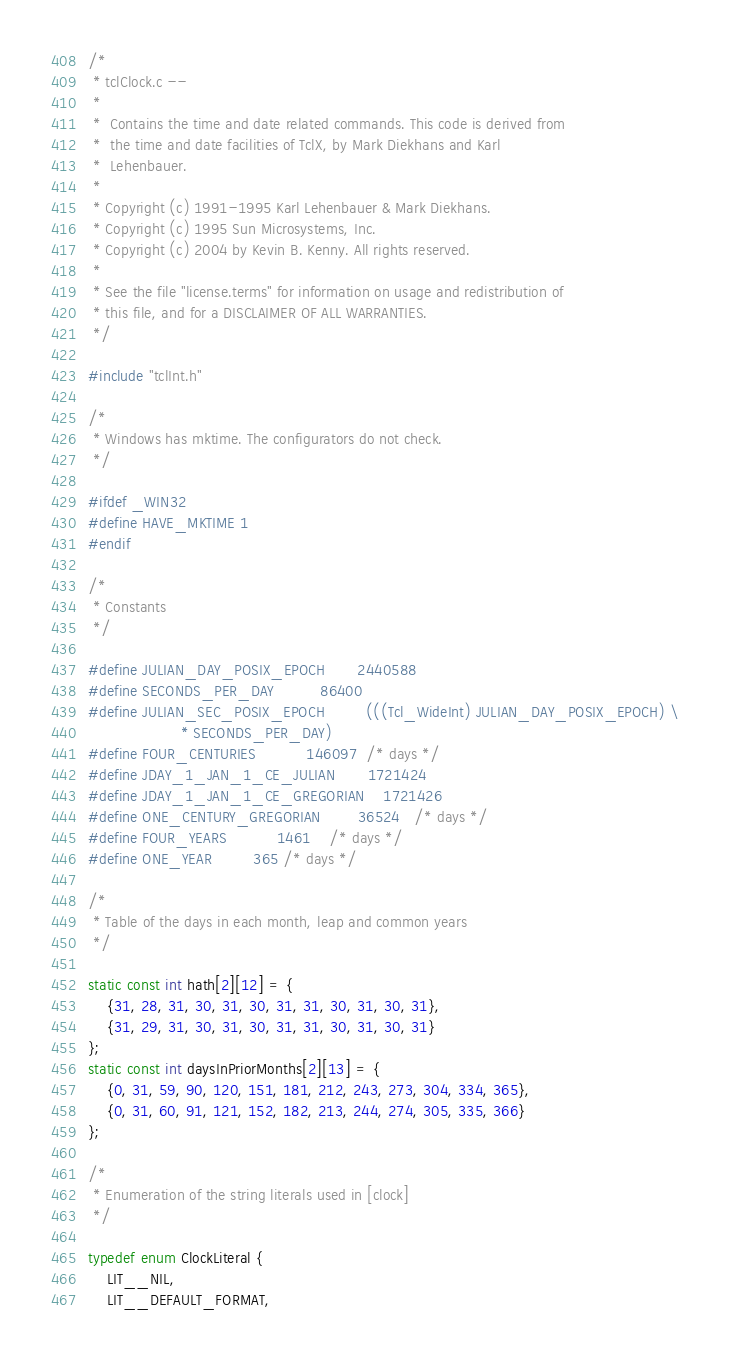<code> <loc_0><loc_0><loc_500><loc_500><_C_>/*
 * tclClock.c --
 *
 *	Contains the time and date related commands. This code is derived from
 *	the time and date facilities of TclX, by Mark Diekhans and Karl
 *	Lehenbauer.
 *
 * Copyright (c) 1991-1995 Karl Lehenbauer & Mark Diekhans.
 * Copyright (c) 1995 Sun Microsystems, Inc.
 * Copyright (c) 2004 by Kevin B. Kenny. All rights reserved.
 *
 * See the file "license.terms" for information on usage and redistribution of
 * this file, and for a DISCLAIMER OF ALL WARRANTIES.
 */

#include "tclInt.h"

/*
 * Windows has mktime. The configurators do not check.
 */

#ifdef _WIN32
#define HAVE_MKTIME 1
#endif

/*
 * Constants
 */

#define JULIAN_DAY_POSIX_EPOCH		2440588
#define SECONDS_PER_DAY			86400
#define JULIAN_SEC_POSIX_EPOCH	      (((Tcl_WideInt) JULIAN_DAY_POSIX_EPOCH) \
					* SECONDS_PER_DAY)
#define FOUR_CENTURIES			146097	/* days */
#define JDAY_1_JAN_1_CE_JULIAN		1721424
#define JDAY_1_JAN_1_CE_GREGORIAN	1721426
#define ONE_CENTURY_GREGORIAN		36524	/* days */
#define FOUR_YEARS			1461	/* days */
#define ONE_YEAR			365	/* days */

/*
 * Table of the days in each month, leap and common years
 */

static const int hath[2][12] = {
    {31, 28, 31, 30, 31, 30, 31, 31, 30, 31, 30, 31},
    {31, 29, 31, 30, 31, 30, 31, 31, 30, 31, 30, 31}
};
static const int daysInPriorMonths[2][13] = {
    {0, 31, 59, 90, 120, 151, 181, 212, 243, 273, 304, 334, 365},
    {0, 31, 60, 91, 121, 152, 182, 213, 244, 274, 305, 335, 366}
};

/*
 * Enumeration of the string literals used in [clock]
 */

typedef enum ClockLiteral {
    LIT__NIL,
    LIT__DEFAULT_FORMAT,</code> 